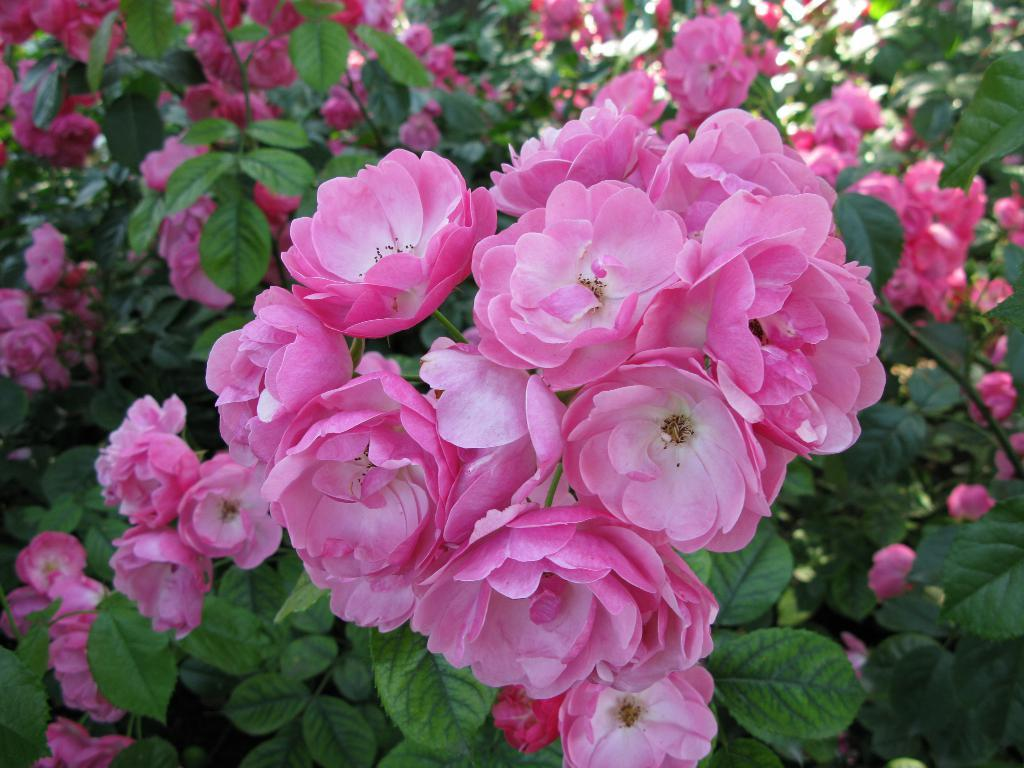What is present in the image? There is a plant in the image. What can be observed about the plant's flowers? The plant has pink flowers. What type of badge is attached to the plant in the image? There is no badge present in the image; it is a plant with pink flowers. How many clovers can be seen growing alongside the plant in the image? There is no mention of clovers in the image; it only features a plant with pink flowers. 